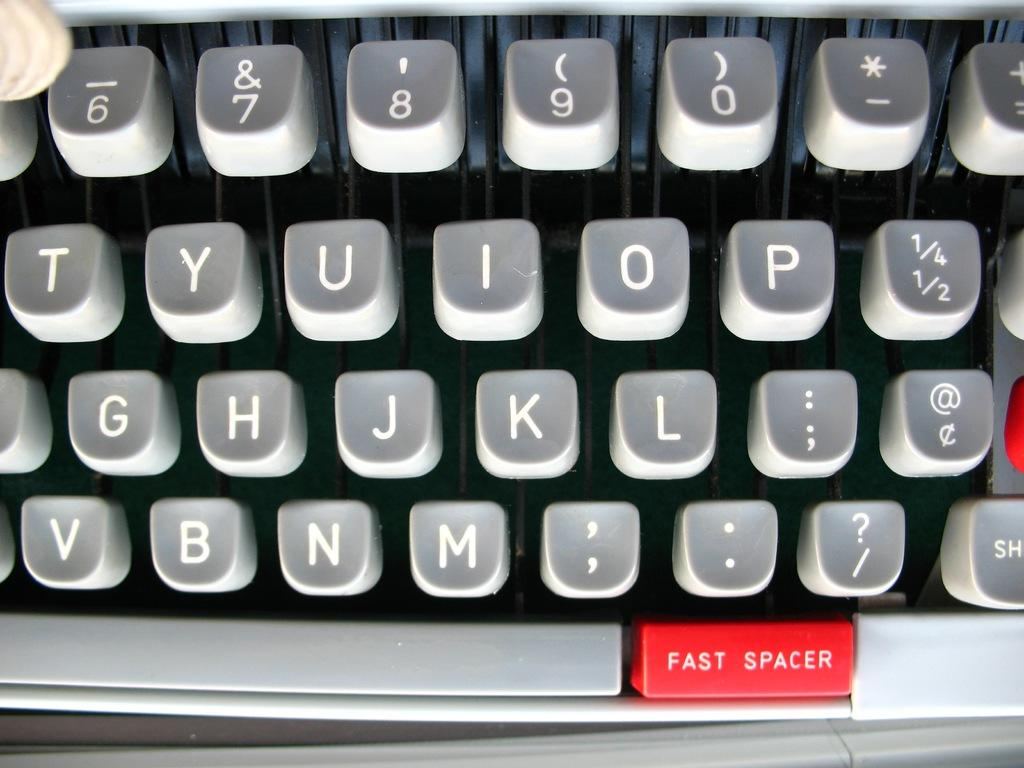<image>
Relay a brief, clear account of the picture shown. Computer keyboard with a key that is red and has "Fast Spacer" on it. 